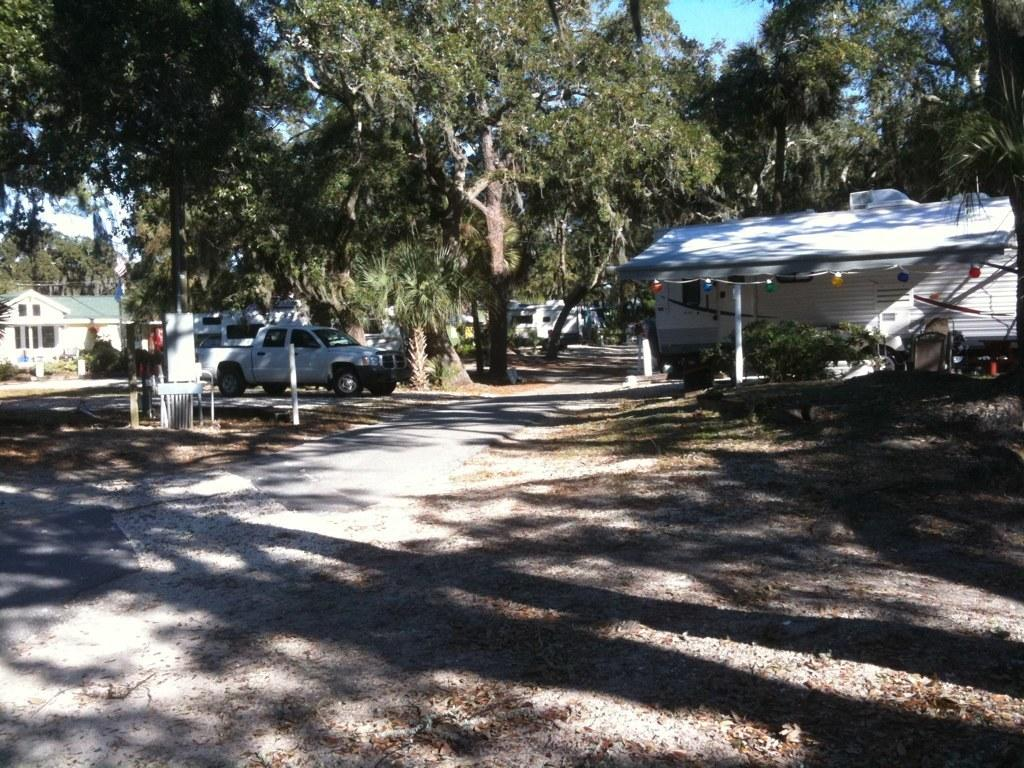What type of landscape is depicted in the image? There is an open land in the image. What structures are located in front of the open land? There are houses in front of the open land. What vehicle can be seen parked between the houses? A truck is parked between the houses. What type of vegetation is present beside the truck? Trees are present beside the truck. What type of brick is used to build the organization in the image? There is no organization present in the image, and therefore no brick can be associated with it. 